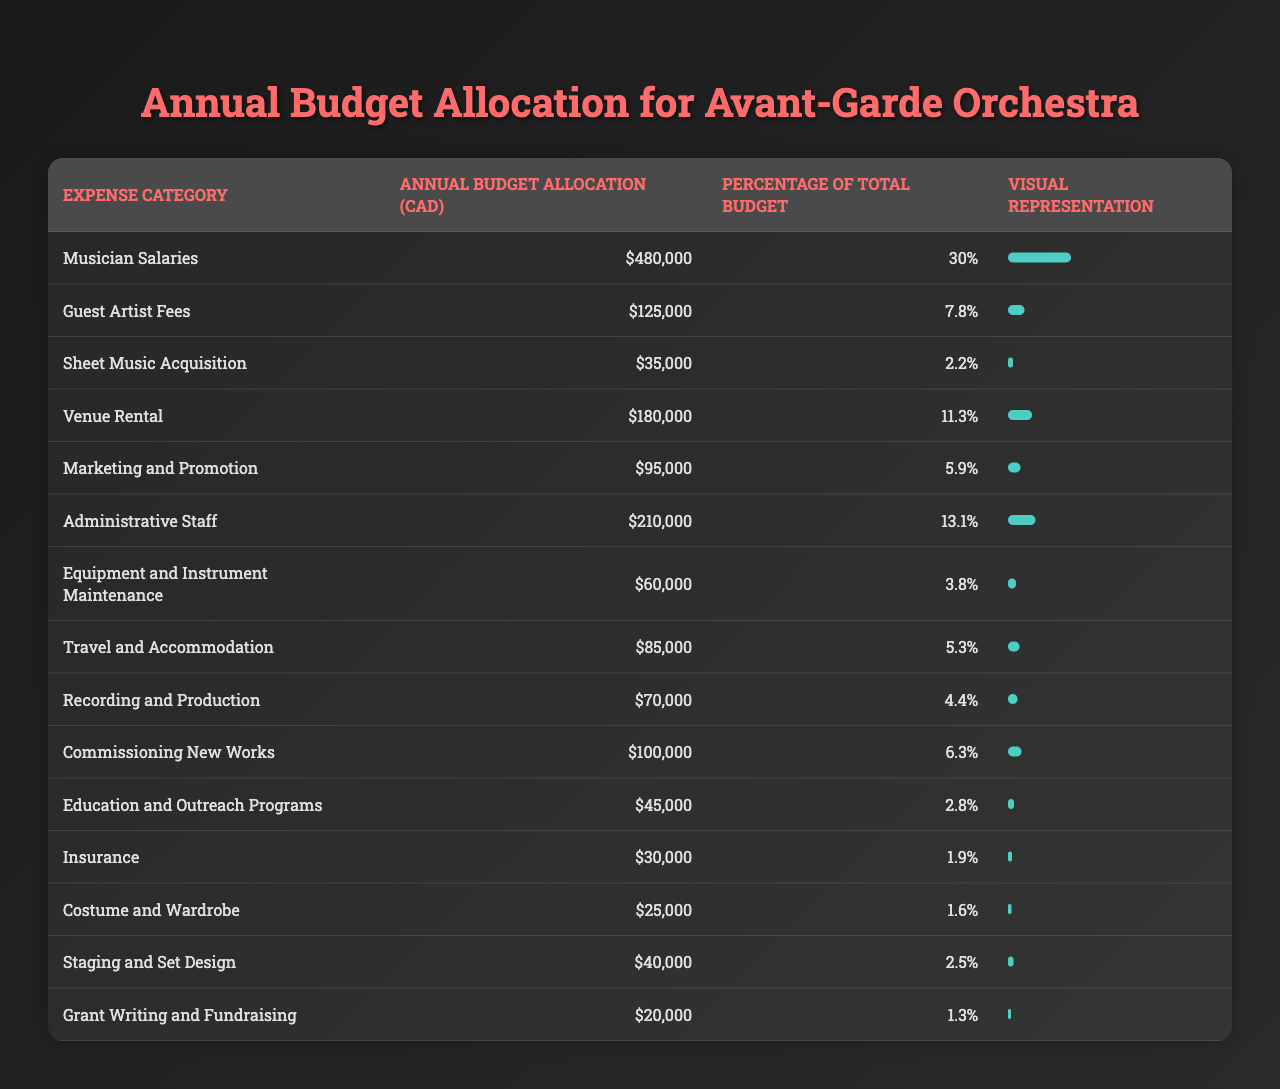What is the highest expense category in the budget allocation? By reviewing the "Annual Budget Allocation (CAD)" column, we can see that "Musician Salaries" has the highest allocation of CAD 480,000.
Answer: Musician Salaries What percentage of the total budget is allocated to Guest Artist Fees? Looking at the "Percentage of Total Budget" column for "Guest Artist Fees," it shows 7.8%.
Answer: 7.8% How much do Travel and Accommodation expenses compare to Insurance expenses? "Travel and Accommodation" has an allocation of CAD 85,000, while "Insurance" has CAD 30,000. The difference is 85,000 - 30,000 = 55,000.
Answer: 55,000 CAD What is the total budget allocated for Marketing and Promotion, and Recording and Production combined? "Marketing and Promotion" has a budget of CAD 95,000 and "Recording and Production" has CAD 70,000. Adding them gives 95,000 + 70,000 = 165,000 CAD.
Answer: 165,000 CAD Is the budget allocation for Administrative Staff greater than the combined total of Costume and Wardrobe and Staging and Set Design? The budget for "Administrative Staff" is CAD 210,000. The combined total for "Costume and Wardrobe" (25,000) and "Staging and Set Design" (40,000) is 25,000 + 40,000 = 65,000. Since 210,000 > 65,000, the answer is yes.
Answer: Yes What is the average budget allocation for the eleven expense categories excluding the lowest three allocations? The expense categories excluding the lowest three ("Costume and Wardrobe", "Insurance", and "Grant Writing and Fundraising") includes Musician Salaries, Guest Artist Fees, Sheet Music Acquisition, Venue Rental, Marketing and Promotion, Administrative Staff, Equipment and Instrument Maintenance, Travel and Accommodation, Recording and Production, and Commissioning New Works. The total allocation for these is 480,000 + 125,000 + 35,000 + 180,000 + 95,000 + 210,000 + 60,000 + 85,000 + 70,000 + 100,000 = 1,370,000 CAD. With 10 categories, the average is 1,370,000 / 10 = 137,000 CAD.
Answer: 137,000 CAD What is the total percentage of the budget allocated to the top three expense categories? The top three expense categories are "Musician Salaries" (30%), "Administrative Staff" (13.1%), and "Venue Rental" (11.3%). Adding these together gives 30 + 13.1 + 11.3 = 54.4%.
Answer: 54.4% Is the budget allocated to Commissioning New Works higher than that for Education and Outreach Programs? The budget for "Commissioning New Works" is CAD 100,000, whereas "Education and Outreach Programs" has CAD 45,000. Since 100,000 > 45,000, the answer is yes.
Answer: Yes What is the difference in budget allocation between the highest and lowest expense categories? The highest budget allocation is for "Musician Salaries" at CAD 480,000, while the lowest is "Grant Writing and Fundraising" at CAD 20,000. The difference is 480,000 - 20,000 = 460,000.
Answer: 460,000 CAD 